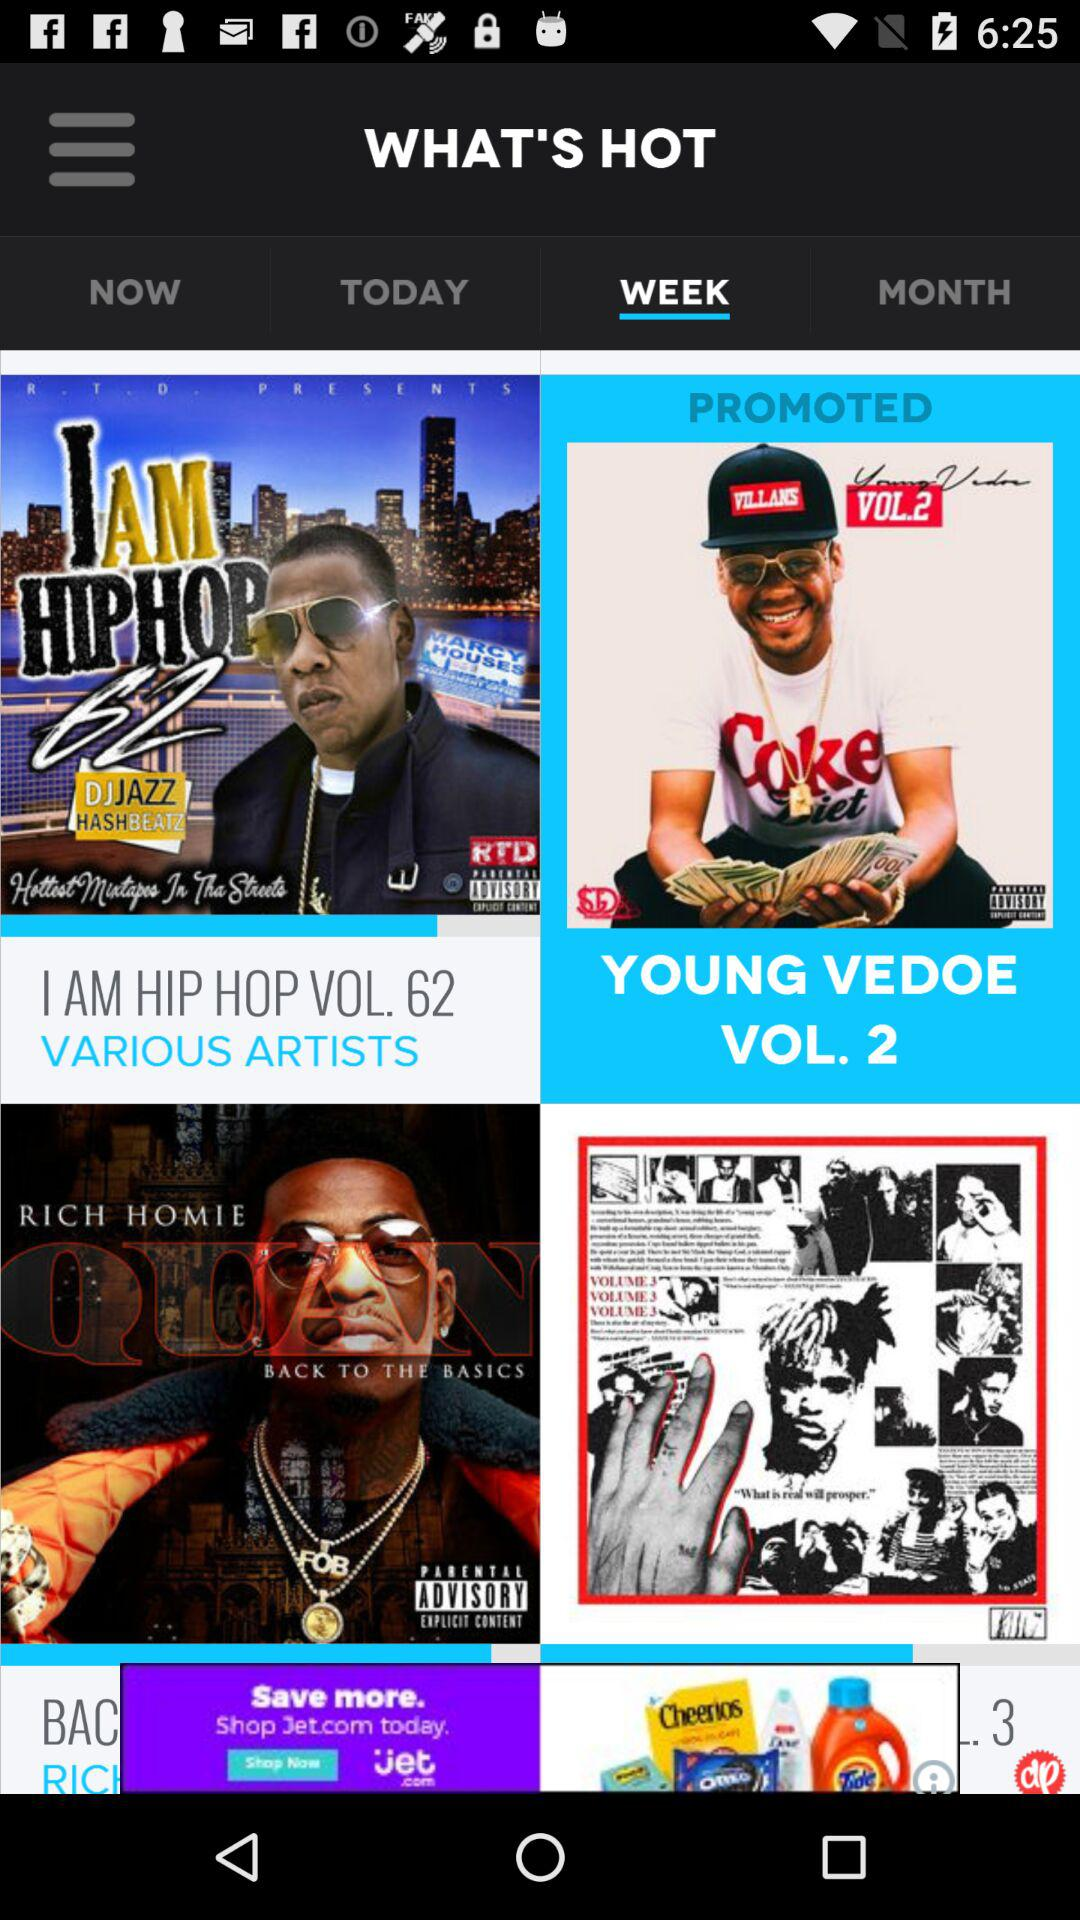Who is the singer of the ‘I am hip hop vol 62’ album? The singer is "DJJAZZ HASHBEATZ". 